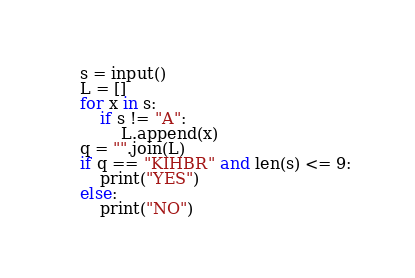Convert code to text. <code><loc_0><loc_0><loc_500><loc_500><_Python_>s = input()
L = []
for x in s:
    if s != "A":
        L.append(x)
q = "".join(L)
if q == "KIHBR" and len(s) <= 9:
    print("YES")
else:
    print("NO")</code> 